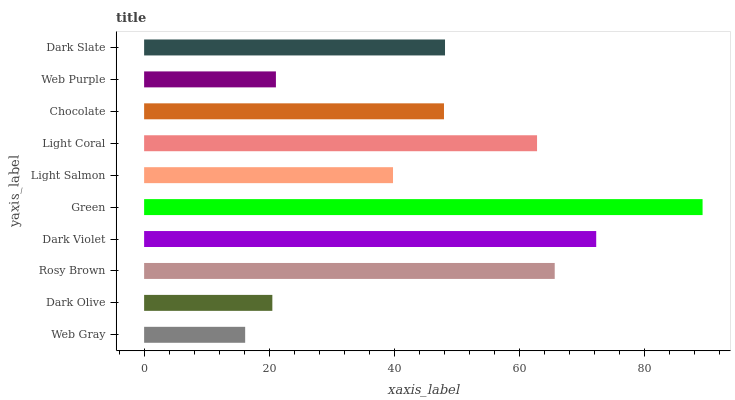Is Web Gray the minimum?
Answer yes or no. Yes. Is Green the maximum?
Answer yes or no. Yes. Is Dark Olive the minimum?
Answer yes or no. No. Is Dark Olive the maximum?
Answer yes or no. No. Is Dark Olive greater than Web Gray?
Answer yes or no. Yes. Is Web Gray less than Dark Olive?
Answer yes or no. Yes. Is Web Gray greater than Dark Olive?
Answer yes or no. No. Is Dark Olive less than Web Gray?
Answer yes or no. No. Is Dark Slate the high median?
Answer yes or no. Yes. Is Chocolate the low median?
Answer yes or no. Yes. Is Light Coral the high median?
Answer yes or no. No. Is Web Purple the low median?
Answer yes or no. No. 